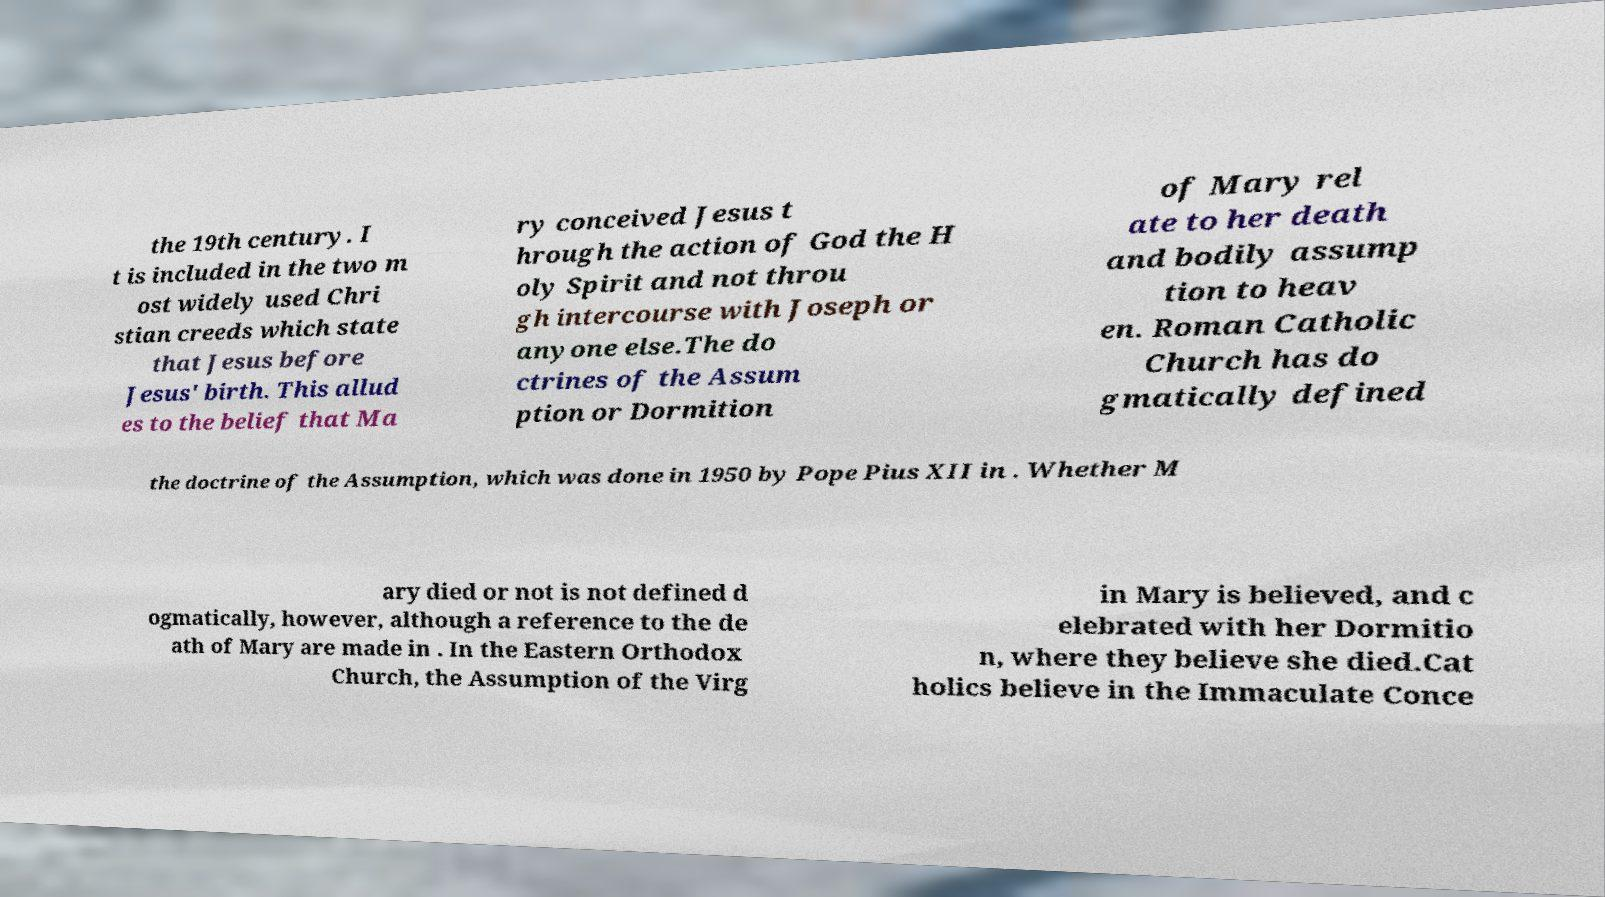There's text embedded in this image that I need extracted. Can you transcribe it verbatim? the 19th century. I t is included in the two m ost widely used Chri stian creeds which state that Jesus before Jesus' birth. This allud es to the belief that Ma ry conceived Jesus t hrough the action of God the H oly Spirit and not throu gh intercourse with Joseph or anyone else.The do ctrines of the Assum ption or Dormition of Mary rel ate to her death and bodily assump tion to heav en. Roman Catholic Church has do gmatically defined the doctrine of the Assumption, which was done in 1950 by Pope Pius XII in . Whether M ary died or not is not defined d ogmatically, however, although a reference to the de ath of Mary are made in . In the Eastern Orthodox Church, the Assumption of the Virg in Mary is believed, and c elebrated with her Dormitio n, where they believe she died.Cat holics believe in the Immaculate Conce 